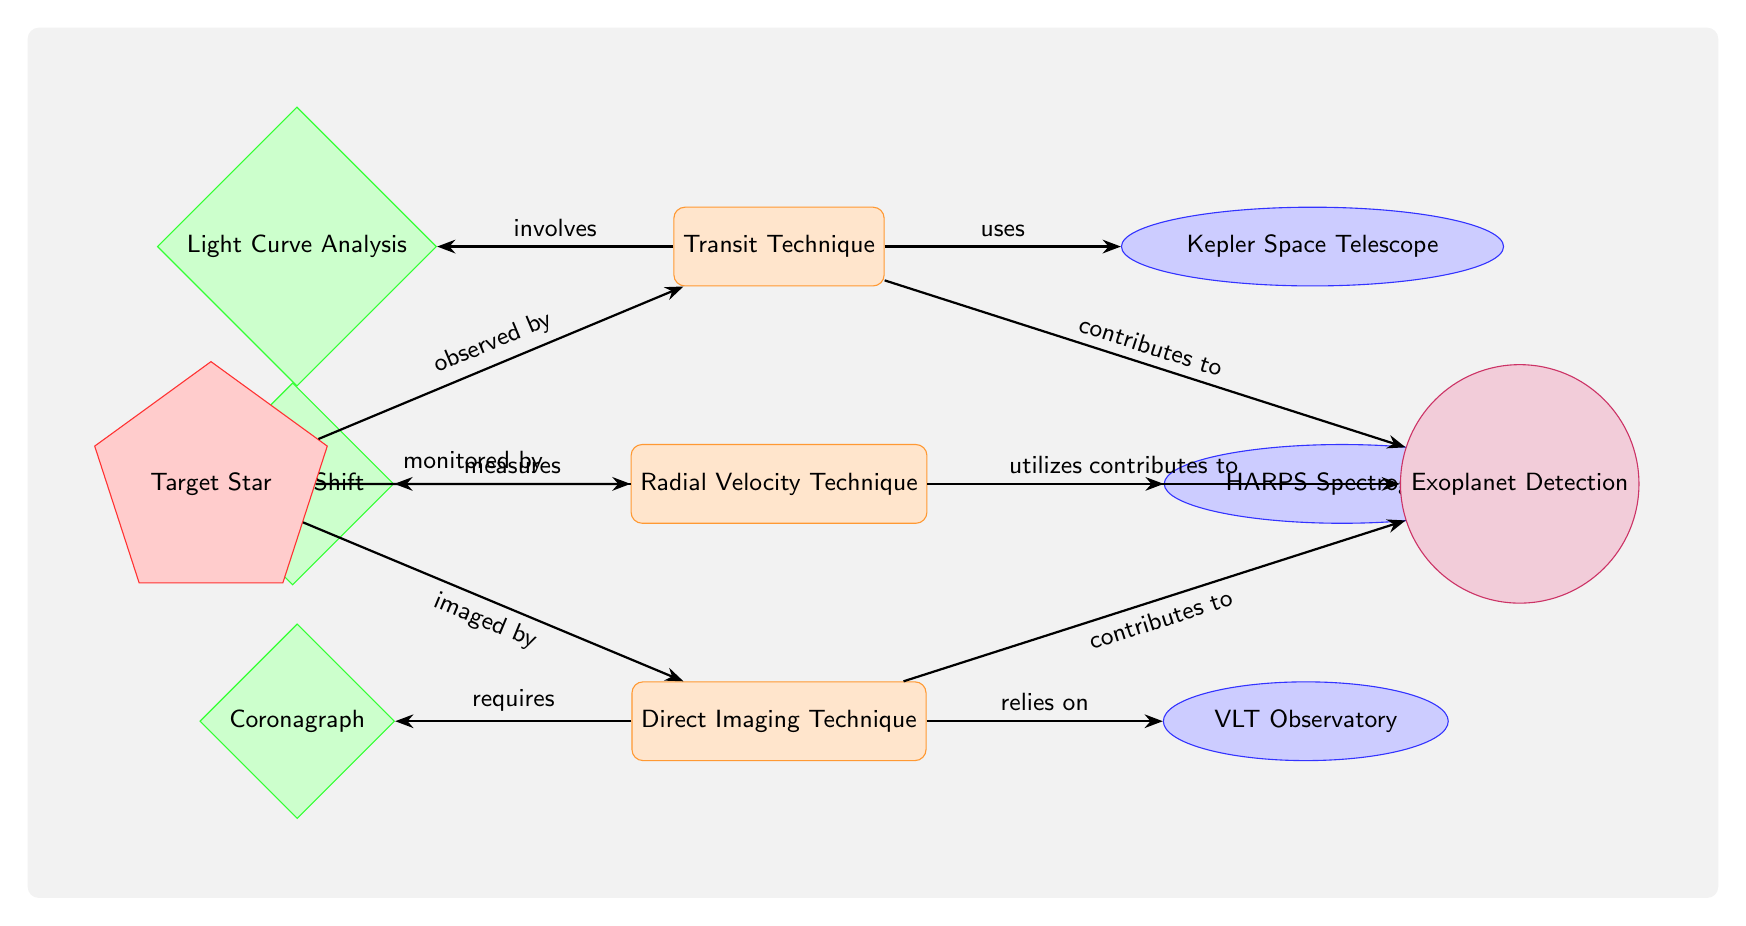What are the three exoplanet detection techniques shown? The diagram outlines three techniques: Transit Technique, Radial Velocity Technique, and Direct Imaging Technique. These are placed in the top three nodes of the diagram, each distinctly labeled.
Answer: Transit Technique, Radial Velocity Technique, Direct Imaging Technique Which instrument is associated with the Transit Technique? The Transit Technique is linked to the Kepler Space Telescope, indicated by an arrow from the Transit node pointing to the Kepler node on the right.
Answer: Kepler Space Telescope What method is used in the Radial Velocity Technique? The Radial Velocity Technique utilizes the Doppler Shift method, as shown by the arrow connecting the Radial node to the Doppler node on the left side.
Answer: Doppler Shift How many instruments are mentioned in the diagram? There are three instruments specified in the diagram: Kepler Space Telescope, HARPS Spectrograph, and VLT Observatory, each corresponding to the three detection techniques.
Answer: 3 Which detection technique requires a coronagraph? The Direct Imaging Technique requires a coronagraph, as indicated by the arrow from the Direct node pointing to the Coronagraph node on the left.
Answer: Coronagraph If the target star is observed by the Transit Technique, which detection technique is also monitored? The Radial Velocity Technique also monitors the same target star, as indicated by the parallel arrow from the Target Star node to the Radial node.
Answer: Radial Velocity Technique Which technique is involved with light curve analysis? The technique involved with light curve analysis is the Transit Technique, explicitly associated by the arrow leading from the Transit node to the Light Curve Analysis node to the left.
Answer: Transit Technique What does the Direct Imaging Technique contribute to? The Direct Imaging Technique contributes to Exoplanet Detection, represented by the arrow pointing from the Direct node to the Detection node on the right.
Answer: Exoplanet Detection 